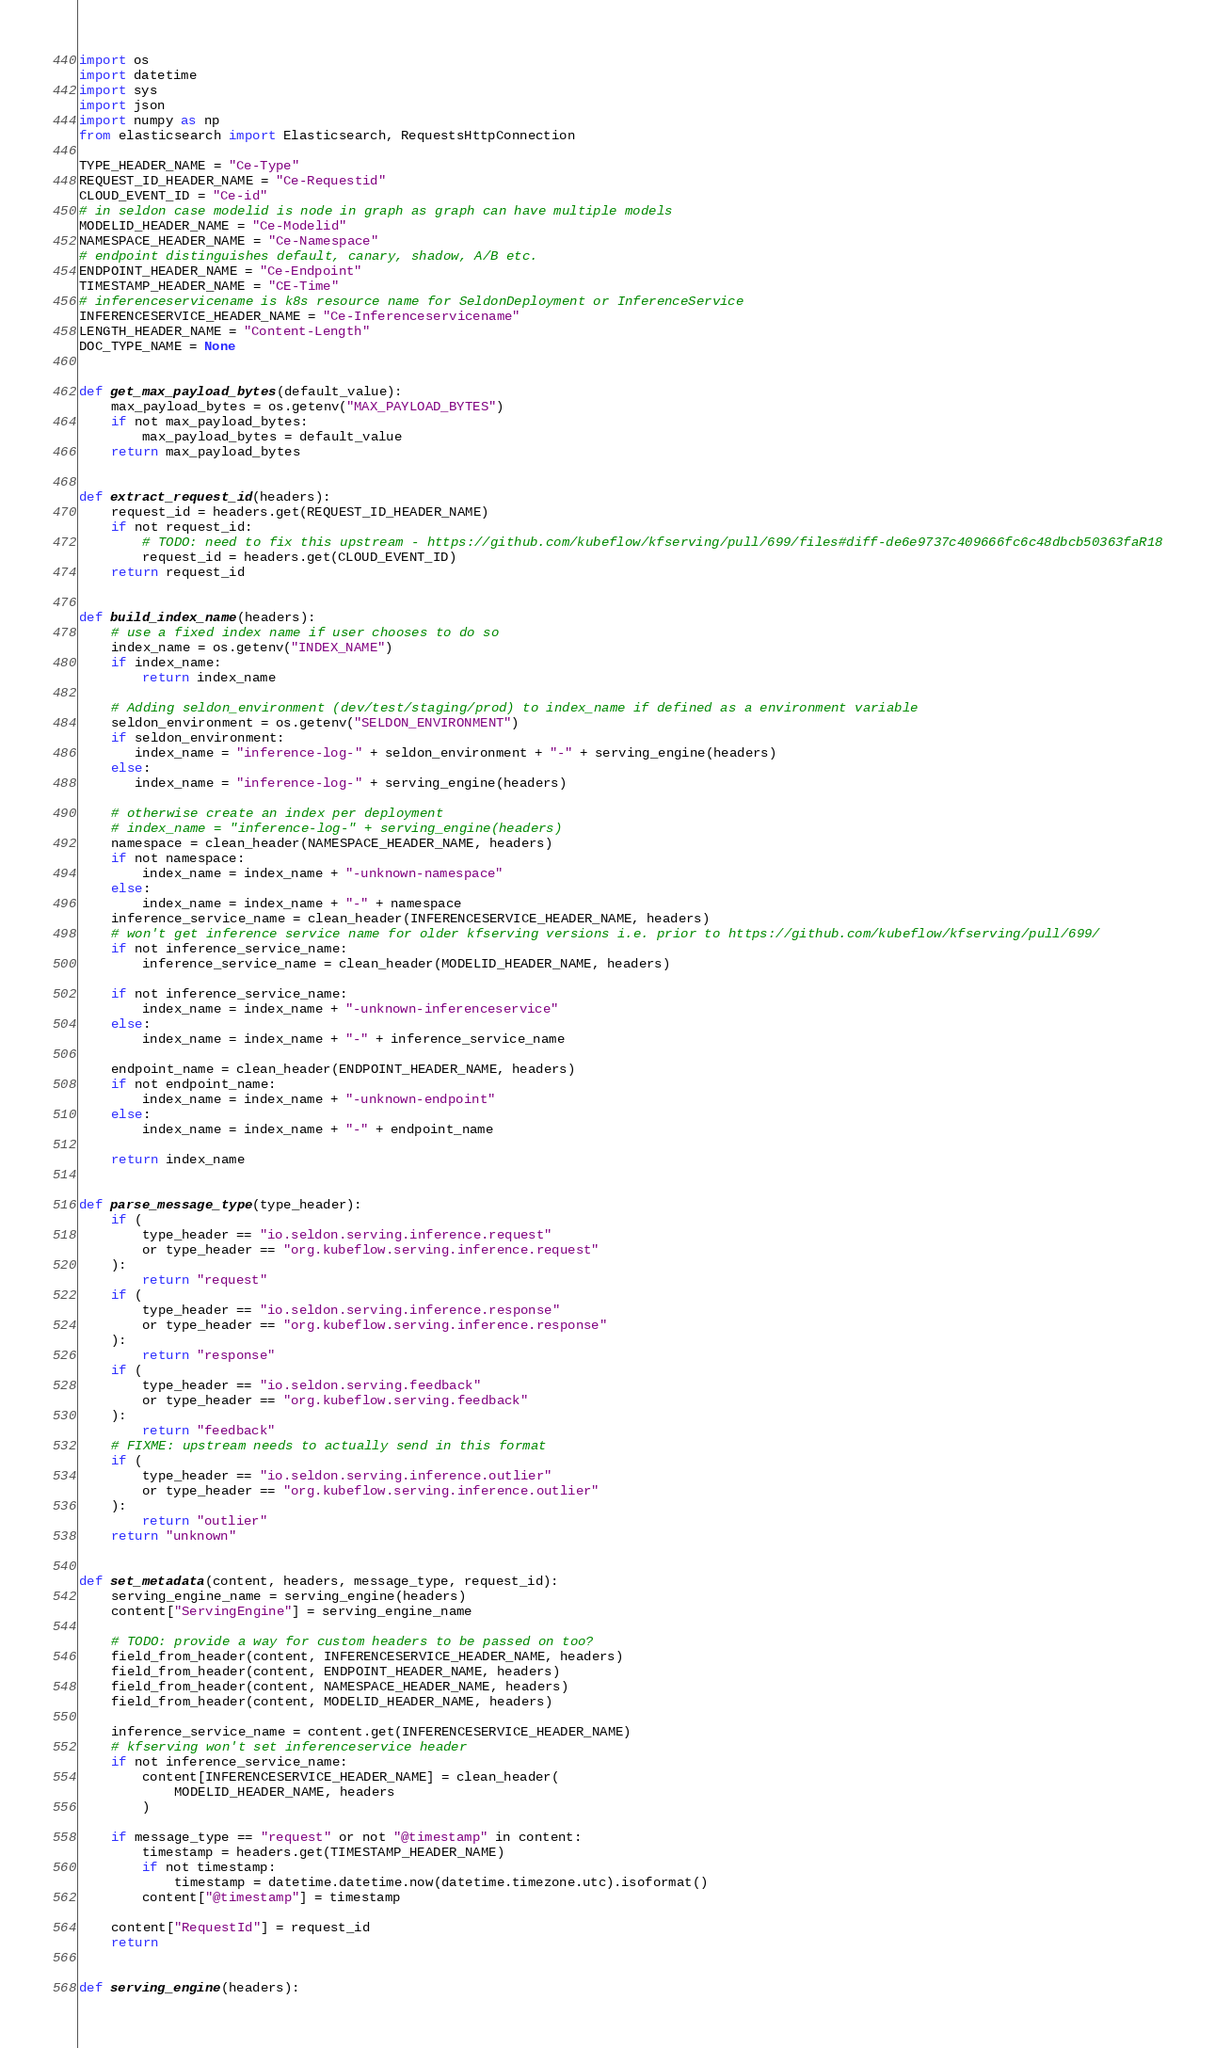<code> <loc_0><loc_0><loc_500><loc_500><_Python_>import os
import datetime
import sys
import json
import numpy as np
from elasticsearch import Elasticsearch, RequestsHttpConnection

TYPE_HEADER_NAME = "Ce-Type"
REQUEST_ID_HEADER_NAME = "Ce-Requestid"
CLOUD_EVENT_ID = "Ce-id"
# in seldon case modelid is node in graph as graph can have multiple models
MODELID_HEADER_NAME = "Ce-Modelid"
NAMESPACE_HEADER_NAME = "Ce-Namespace"
# endpoint distinguishes default, canary, shadow, A/B etc.
ENDPOINT_HEADER_NAME = "Ce-Endpoint"
TIMESTAMP_HEADER_NAME = "CE-Time"
# inferenceservicename is k8s resource name for SeldonDeployment or InferenceService
INFERENCESERVICE_HEADER_NAME = "Ce-Inferenceservicename"
LENGTH_HEADER_NAME = "Content-Length"
DOC_TYPE_NAME = None


def get_max_payload_bytes(default_value):
    max_payload_bytes = os.getenv("MAX_PAYLOAD_BYTES")
    if not max_payload_bytes:
        max_payload_bytes = default_value
    return max_payload_bytes


def extract_request_id(headers):
    request_id = headers.get(REQUEST_ID_HEADER_NAME)
    if not request_id:
        # TODO: need to fix this upstream - https://github.com/kubeflow/kfserving/pull/699/files#diff-de6e9737c409666fc6c48dbcb50363faR18
        request_id = headers.get(CLOUD_EVENT_ID)
    return request_id


def build_index_name(headers):
    # use a fixed index name if user chooses to do so
    index_name = os.getenv("INDEX_NAME")
    if index_name:
        return index_name
    
    # Adding seldon_environment (dev/test/staging/prod) to index_name if defined as a environment variable
    seldon_environment = os.getenv("SELDON_ENVIRONMENT")
    if seldon_environment:
       index_name = "inference-log-" + seldon_environment + "-" + serving_engine(headers)
    else:
       index_name = "inference-log-" + serving_engine(headers)
    
    # otherwise create an index per deployment
    # index_name = "inference-log-" + serving_engine(headers)
    namespace = clean_header(NAMESPACE_HEADER_NAME, headers)
    if not namespace:
        index_name = index_name + "-unknown-namespace"
    else:
        index_name = index_name + "-" + namespace
    inference_service_name = clean_header(INFERENCESERVICE_HEADER_NAME, headers)
    # won't get inference service name for older kfserving versions i.e. prior to https://github.com/kubeflow/kfserving/pull/699/
    if not inference_service_name:
        inference_service_name = clean_header(MODELID_HEADER_NAME, headers)

    if not inference_service_name:
        index_name = index_name + "-unknown-inferenceservice"
    else:
        index_name = index_name + "-" + inference_service_name

    endpoint_name = clean_header(ENDPOINT_HEADER_NAME, headers)
    if not endpoint_name:
        index_name = index_name + "-unknown-endpoint"
    else:
        index_name = index_name + "-" + endpoint_name

    return index_name


def parse_message_type(type_header):
    if (
        type_header == "io.seldon.serving.inference.request"
        or type_header == "org.kubeflow.serving.inference.request"
    ):
        return "request"
    if (
        type_header == "io.seldon.serving.inference.response"
        or type_header == "org.kubeflow.serving.inference.response"
    ):
        return "response"
    if (
        type_header == "io.seldon.serving.feedback"
        or type_header == "org.kubeflow.serving.feedback"
    ):
        return "feedback"
    # FIXME: upstream needs to actually send in this format
    if (
        type_header == "io.seldon.serving.inference.outlier"
        or type_header == "org.kubeflow.serving.inference.outlier"
    ):
        return "outlier"
    return "unknown"


def set_metadata(content, headers, message_type, request_id):
    serving_engine_name = serving_engine(headers)
    content["ServingEngine"] = serving_engine_name

    # TODO: provide a way for custom headers to be passed on too?
    field_from_header(content, INFERENCESERVICE_HEADER_NAME, headers)
    field_from_header(content, ENDPOINT_HEADER_NAME, headers)
    field_from_header(content, NAMESPACE_HEADER_NAME, headers)
    field_from_header(content, MODELID_HEADER_NAME, headers)

    inference_service_name = content.get(INFERENCESERVICE_HEADER_NAME)
    # kfserving won't set inferenceservice header
    if not inference_service_name:
        content[INFERENCESERVICE_HEADER_NAME] = clean_header(
            MODELID_HEADER_NAME, headers
        )

    if message_type == "request" or not "@timestamp" in content:
        timestamp = headers.get(TIMESTAMP_HEADER_NAME)
        if not timestamp:
            timestamp = datetime.datetime.now(datetime.timezone.utc).isoformat()
        content["@timestamp"] = timestamp

    content["RequestId"] = request_id
    return


def serving_engine(headers):</code> 